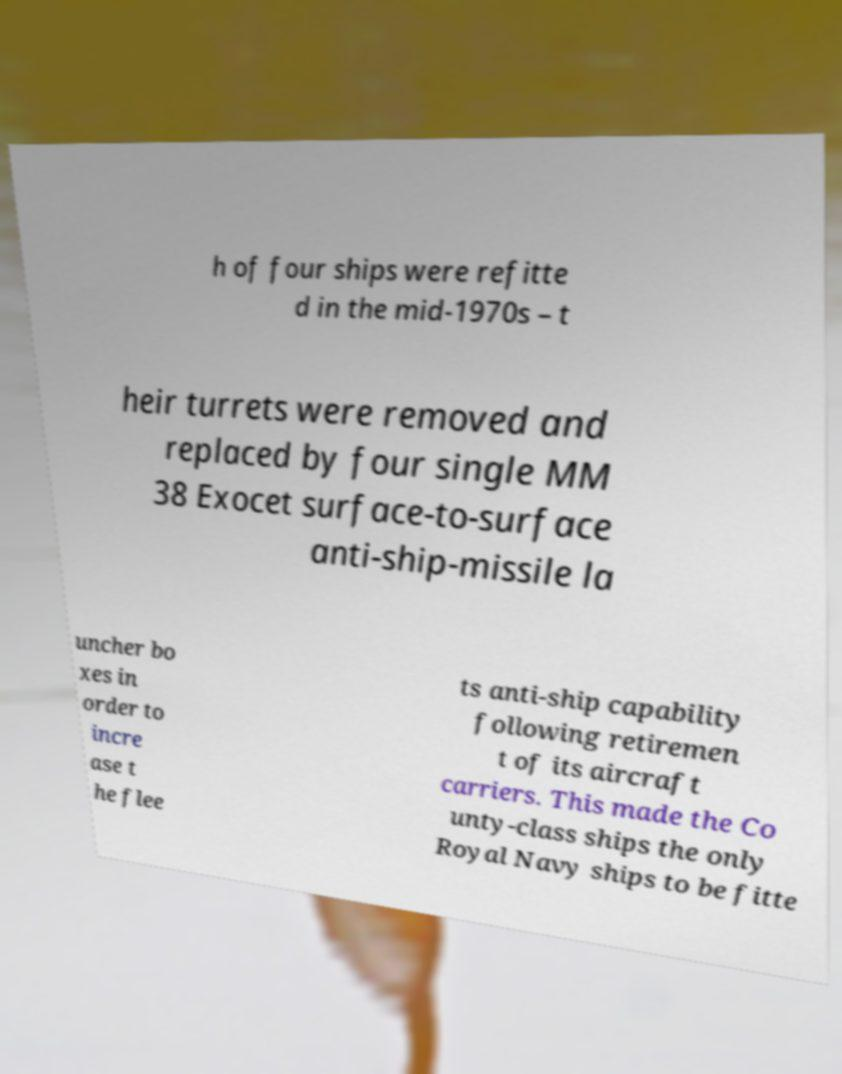For documentation purposes, I need the text within this image transcribed. Could you provide that? h of four ships were refitte d in the mid-1970s – t heir turrets were removed and replaced by four single MM 38 Exocet surface-to-surface anti-ship-missile la uncher bo xes in order to incre ase t he flee ts anti-ship capability following retiremen t of its aircraft carriers. This made the Co unty-class ships the only Royal Navy ships to be fitte 